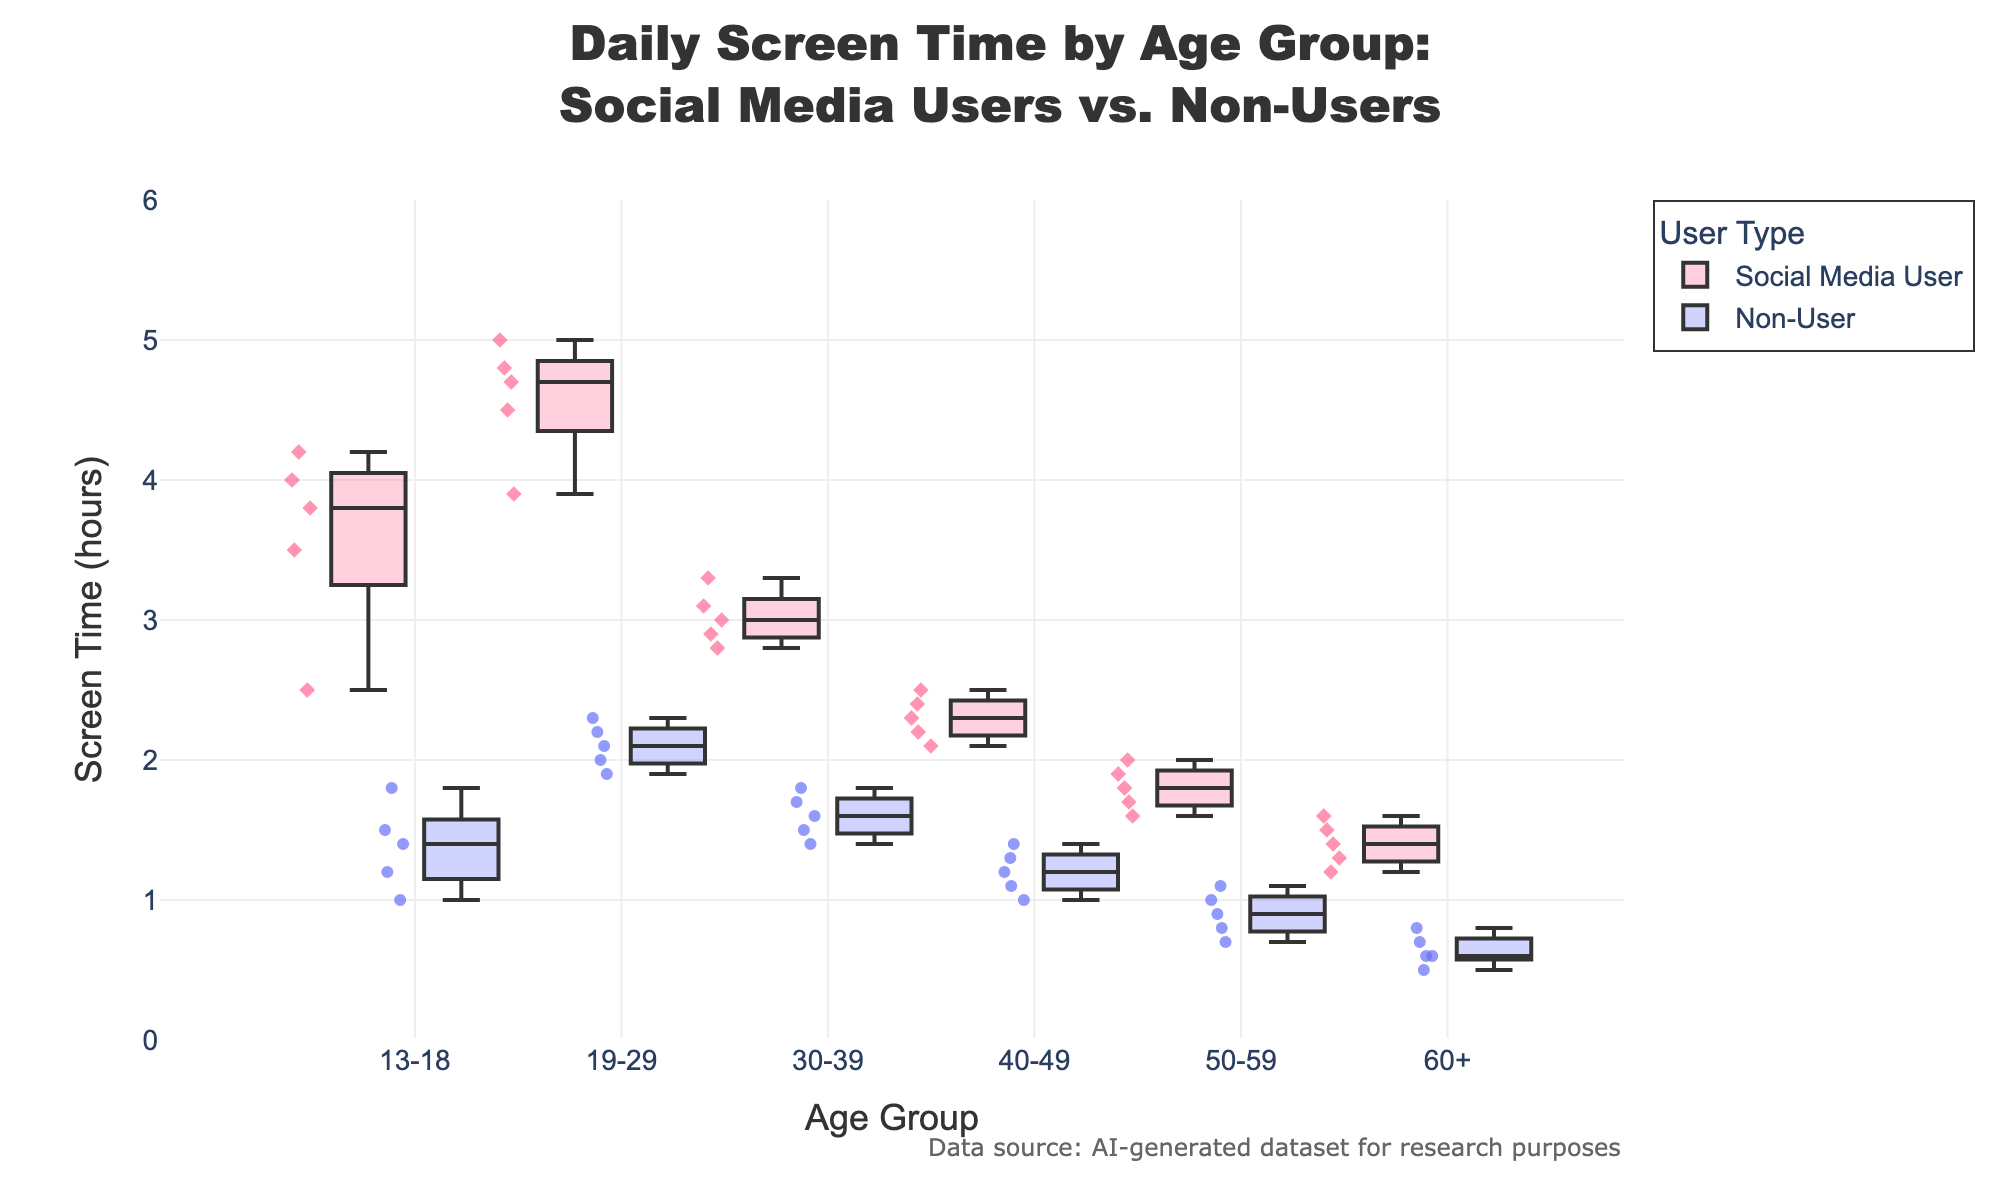What's the title of the figure? The title of the figure is located at the top center of the plot and is displayed in larger font size. It reads "Daily Screen Time by Age Group: Social Media Users vs. Non-Users".
Answer: Daily Screen Time by Age Group: Social Media Users vs. Non-Users Which user type has more screen time in the 19-29 age group? By looking at the box plots for the 19-29 age group, the box for Social Media Users is positioned higher on the y-axis compared to the box for Non-Users, indicating that social media users have more screen time.
Answer: Social Media Users What's the median screen time for 13-18 social media users? The median can be identified by the line inside the box of the box plot for the 13-18 age group of Social Media Users. The position of the median line appears to be around 3.8 hours.
Answer: 3.8 hours How does the average screen time for Non-Users change from the 50-59 to the 60+ age group? The average is roughly midway between the quartiles in a box plot. For the 50-59 Non-Users, the box plot cluster is around 0.8-1.1 hours. For the 60+ Non-Users, it is around 0.6-0.8 hours. The average decreases.
Answer: It decreases What color represents Social Media Users in the plot? Social Media Users are represented by the box plots in a shade of pink. The plot specifically uses a fill color in a shade of pink for Social Media User data points.
Answer: Pink Which age group has the highest range of screen time for Social Media Users? The range is determined by the distance between the minimum and maximum values represented by the box plot. The 19-29 age group has the largest distance between the whiskers, indicating the highest range.
Answer: 19-29 In the 30-39 age group, what is the range of screen time for Non-Users? In the box plot for Non-Users in the 30-39 age group, the range is determined by subtracting the minimum value, which is approximately 1.4 hours, from the maximum value, which is around 1.8 hours. Thus, the range is (1.8 - 1.4 = 0.4 hours).
Answer: 0.4 hours What is the common screen time interval for the 50-59 age group of Non-Users? The common interval, represented by the box of the box plot, is between the first quartile and third quartile. For 50-59 Non-Users, this interval ranges approximately from 0.8 hours to 1.1 hours.
Answer: Between 0.8 and 1.1 hours Which user type has more consistent screen time among 13-18 age group members? More consistent screen time is indicated by a smaller interquartile range. For the 13-18 age group, Non-Users have a smaller interquartile range compared to Social Media Users, suggesting more consistent screen time.
Answer: Non-Users 